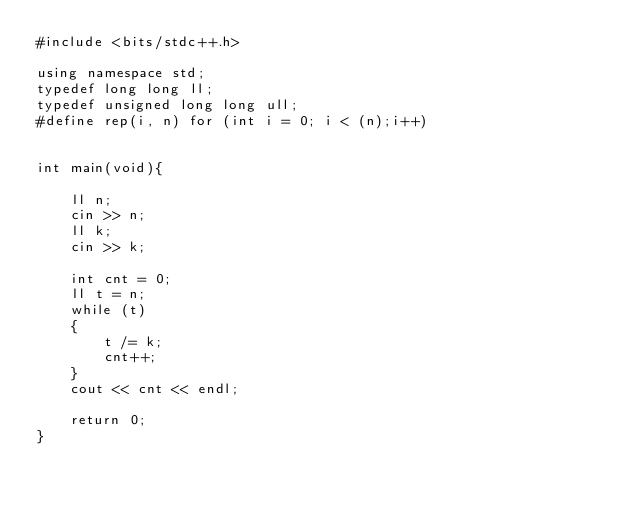<code> <loc_0><loc_0><loc_500><loc_500><_C++_>#include <bits/stdc++.h>

using namespace std;
typedef long long ll;
typedef unsigned long long ull;
#define rep(i, n) for (int i = 0; i < (n);i++)


int main(void){

    ll n;
    cin >> n;
    ll k;
    cin >> k;

    int cnt = 0;
    ll t = n; 
    while (t)
    {
        t /= k;
        cnt++;
    }
    cout << cnt << endl;

    return 0;
}
</code> 